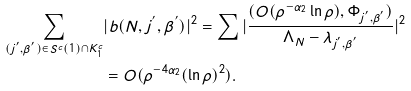Convert formula to latex. <formula><loc_0><loc_0><loc_500><loc_500>\sum _ { ( j ^ { ^ { \prime } } , \beta ^ { ^ { \prime } } ) \in S ^ { c } ( 1 ) \cap K _ { 1 } ^ { c } } & | b ( N , j ^ { ^ { \prime } } , \beta ^ { ^ { \prime } } ) | ^ { 2 } = \sum | \frac { ( O ( \rho ^ { - \alpha _ { 2 } } \ln \rho ) , \Phi _ { j ^ { ^ { \prime } } , \beta ^ { ^ { \prime } } } ) } { \Lambda _ { N } - \lambda _ { j ^ { ^ { \prime } } , \beta ^ { ^ { \prime } } } } | ^ { 2 } \\ & = O ( \rho ^ { - 4 \alpha _ { 2 } } ( \ln \rho ) ^ { 2 } ) .</formula> 